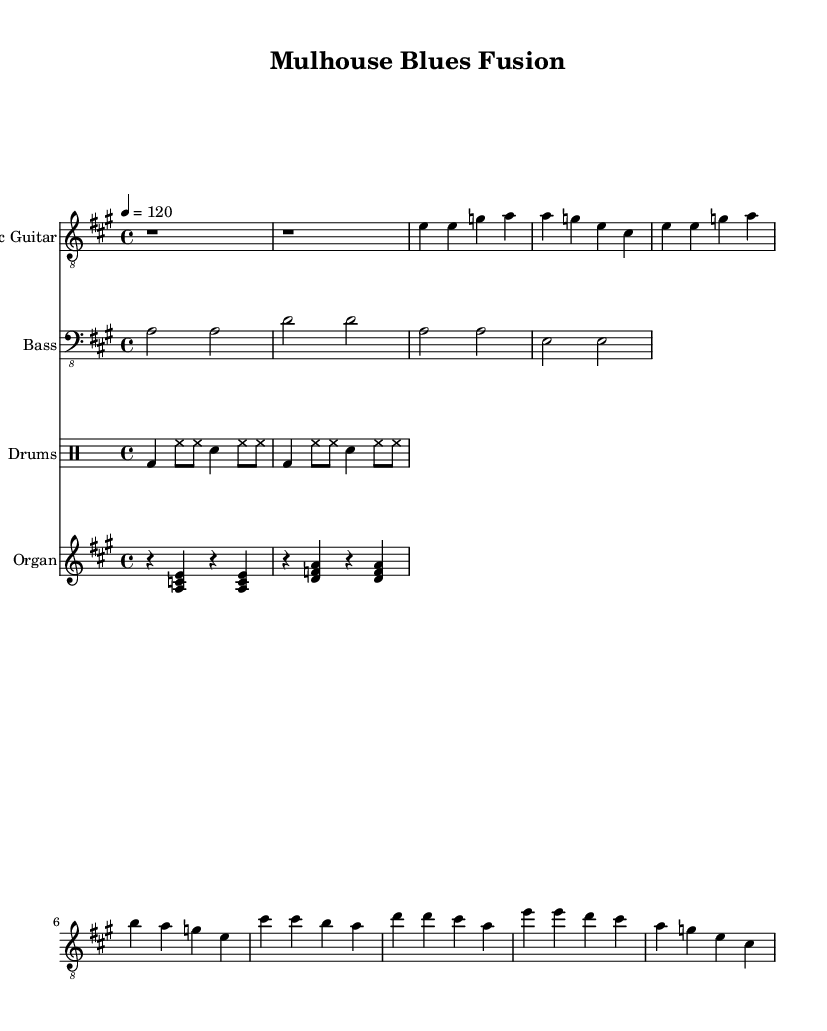What is the key signature of this music? The key signature indicates the notes that are sharp or flat for a piece. In this music, the key signature shows that it is in A major, which has three sharps (F#, C#, and G#).
Answer: A major What is the time signature? The time signature specifies how many beats are in each measure and which note value represents a beat. This music has a time signature of 4/4, meaning there are four beats in each measure, and the quarter note gets one beat.
Answer: 4/4 What is the tempo marking for this piece? The tempo marking indicates the speed of the music. In this piece, it is set at 120 beats per minute, which is the speed at which the quarter note is counted.
Answer: 120 How many measures are in the verse section? To find the number of measures in the verse section, we look at the number of distinct groups of note values that line up in the electric guitar part. There are four measures in the verse section.
Answer: 4 What instruments are included in this score? The instruments can be identified by their respective staves. This score includes Electric Guitar, Bass, Drums, and Organ.
Answer: Electric Guitar, Bass, Drums, Organ What kind of beat is used for the drums section? The drums section contains a typical rock beat which includes kick drum (bd), hi-hat (hh), and snare drum (sn) in a repeating pattern. This pattern is characteristic of the electric blues genre.
Answer: Rock beat 